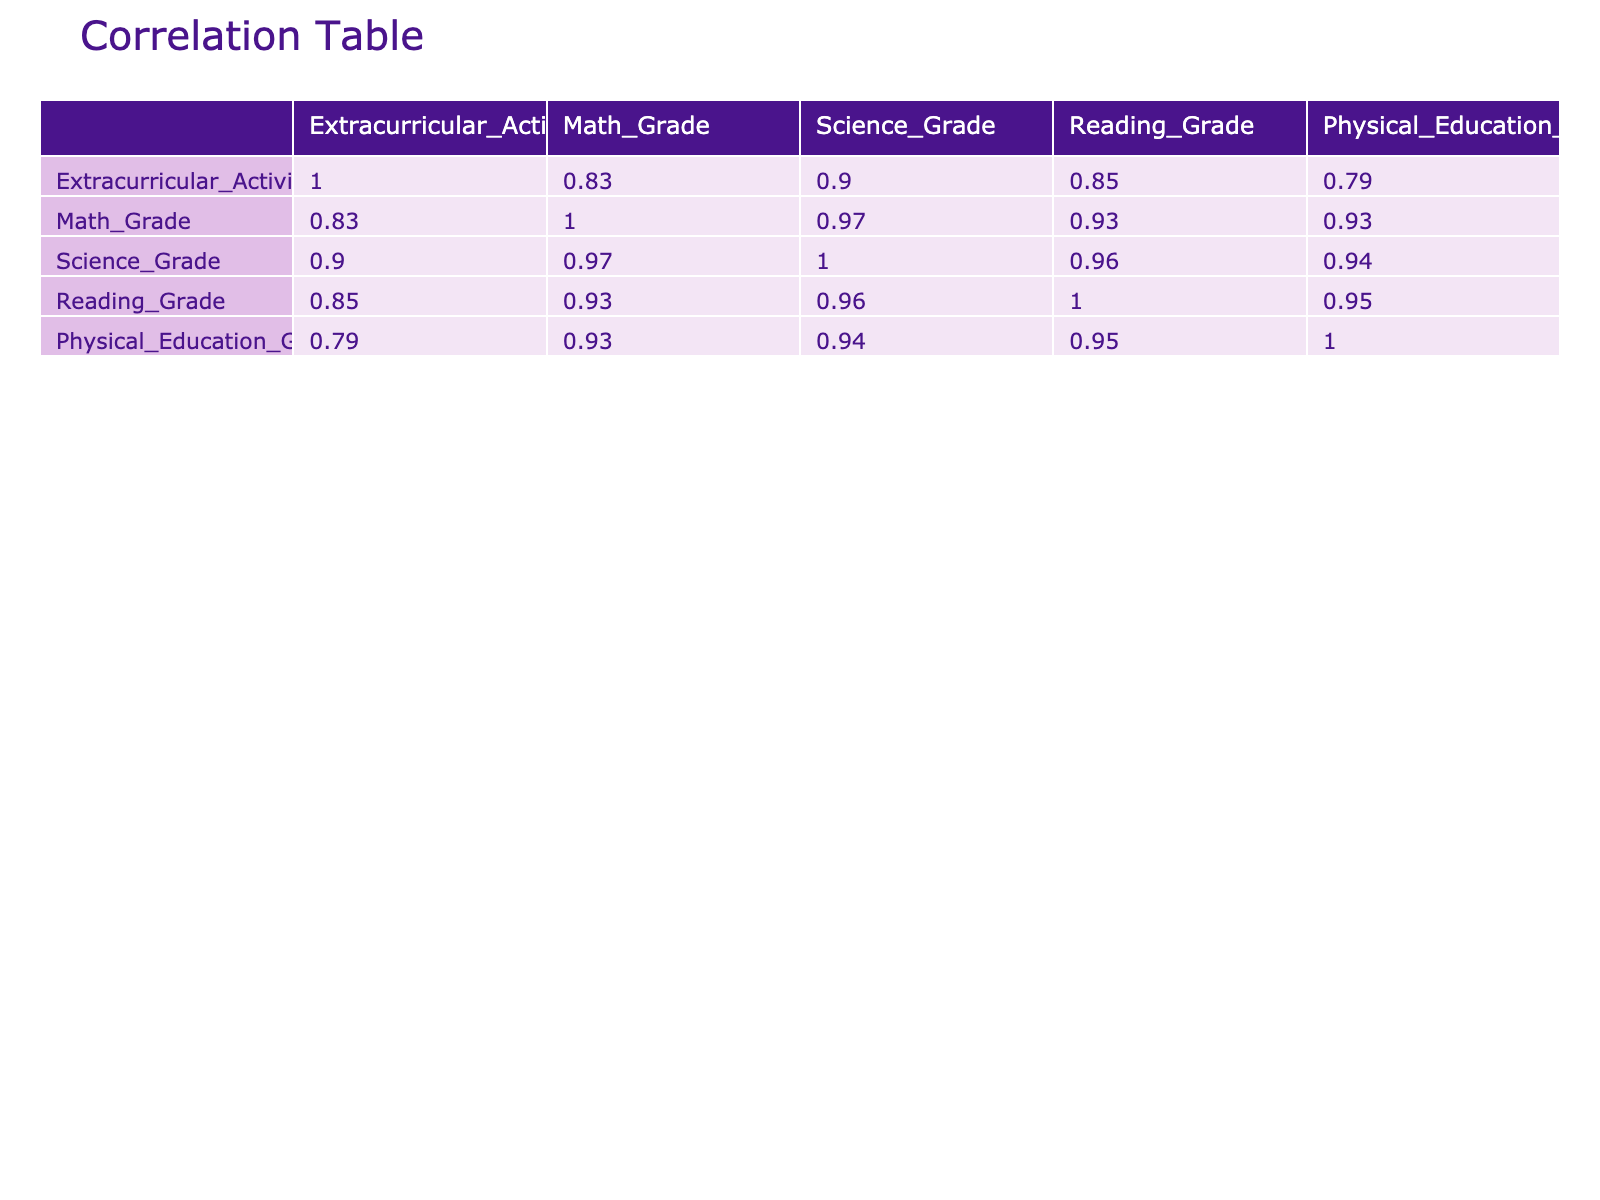What is the correlation coefficient between extracurricular activities hours per week and math grades? To find the correlation coefficient, we refer to the correlation table. In the row for extracurricular activities hours per week and the column for math grades, the value is 0.53.
Answer: 0.53 Which student has the highest reading grade and how many extracurricular activity hours do they participate in per week? Isabella Garcia has the highest reading grade of 95, and she participates in 5 extracurricular activity hours per week.
Answer: Isabella Garcia, 5 What is the average science grade of students who participate in clubs? To find the average science grade of students who participate in clubs, we identify the science grades of those students: 88 (John Smith), 75 (Michael Brown), 85 (Sophia Davis), 89 (Olivia Martinez), and 90 (Isabella Garcia). Summing these grades gives us 88 + 75 + 85 + 89 + 90 = 427. We divide by the number of students (5) to get 427 / 5 = 85.4.
Answer: 85.4 Does participating in extracurricular activities correlate positively with physical education grades? We can check the correlation value between extracurricular activities hours per week and physical education grades in the table, which is 0.87. Since the value is positive, we conclude that they correlate positively.
Answer: Yes What is the lowest science grade among students who participated in extracurricular activities? By examining the science grades of students who participated in extracurricular activities, we find Michael Brown with a science grade of 75. This is the lowest grade among this group.
Answer: 75 How many students scored above 90 in math grades? We review the math grades of each student: 85, 90, 78, 88, 82, 87, 76, 92, 70, and 95. The students with math grades above 90 are Emily Johnson (90), Isabella Garcia (92), and Ava Hernandez (95), totaling 3 students.
Answer: 3 What is the average extracurricular activity hours for students with a physical education grade above 90? We identify the students with physical education grades above 90, which are John Smith (95), Sophia Davis (92), Olivia Martinez (93), and Ava Hernandez (96). Their extracurricular activity hours are 5, 4, 8, and 9, respectively. Summing these gives 5 + 4 + 8 + 9 = 26, and we divide by the number of students (4) to get an average of 26 / 4 = 6.5.
Answer: 6.5 Is there a student who participated in clubs but has a physical education grade lower than 90? Reviewing the students who participated in clubs, the grades are: John Smith (95), Michael Brown (88), Sophia Davis (92), Olivia Martinez (93), and Isabella Garcia (97). The lowest physical education grade in this group is 88 (Michael Brown), which is less than 90.
Answer: Yes 